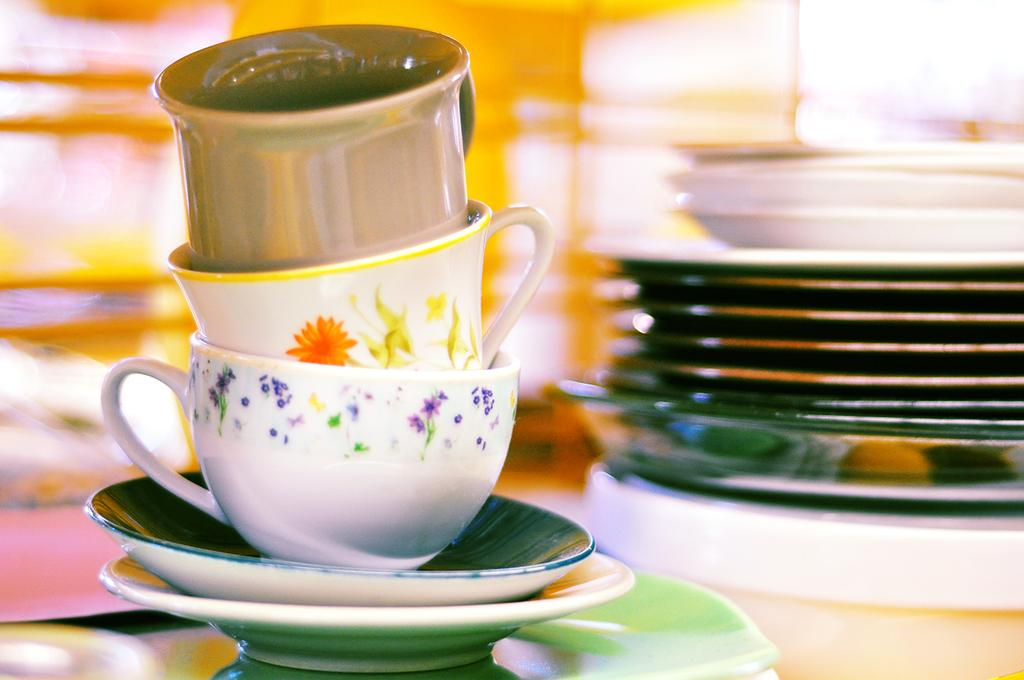How many cups are visible in the image? There are three cups in the image. What other items are present in the image that are related to the cups? There are three saucers in the image. Are there any other tableware items visible in the image? Yes, there are three plates in the image. Can you describe the background of the image? The background of the image is blurry. What type of humor can be found in the image? There is no humor present in the image; it features three cups, three saucers, and three plates. What type of meal is being prepared in the image? There is no meal preparation visible in the image; it only shows tableware items. 